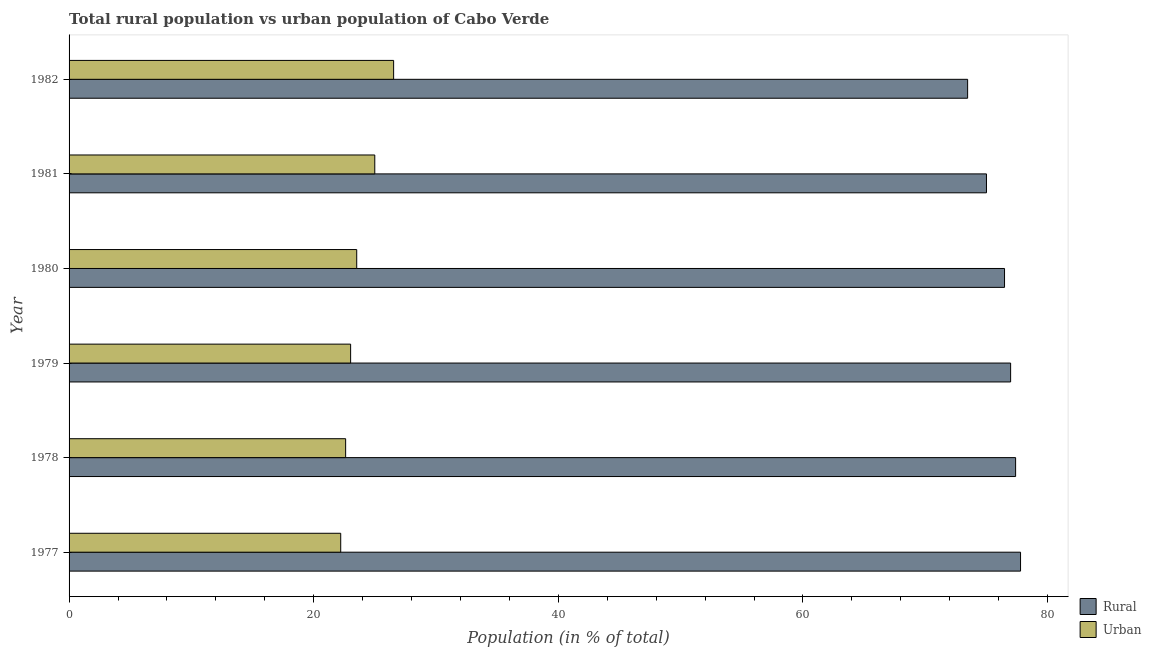How many groups of bars are there?
Your answer should be very brief. 6. Are the number of bars on each tick of the Y-axis equal?
Give a very brief answer. Yes. How many bars are there on the 3rd tick from the top?
Offer a terse response. 2. What is the label of the 5th group of bars from the top?
Your answer should be compact. 1978. In how many cases, is the number of bars for a given year not equal to the number of legend labels?
Your response must be concise. 0. What is the urban population in 1980?
Your answer should be compact. 23.52. Across all years, what is the maximum rural population?
Your answer should be compact. 77.79. Across all years, what is the minimum rural population?
Give a very brief answer. 73.47. In which year was the urban population minimum?
Your response must be concise. 1977. What is the total rural population in the graph?
Ensure brevity in your answer.  457.11. What is the difference between the urban population in 1979 and that in 1982?
Make the answer very short. -3.52. What is the difference between the urban population in 1977 and the rural population in 1978?
Provide a short and direct response. -55.18. What is the average rural population per year?
Your response must be concise. 76.19. In the year 1977, what is the difference between the urban population and rural population?
Keep it short and to the point. -55.58. In how many years, is the urban population greater than 32 %?
Provide a short and direct response. 0. What is the ratio of the rural population in 1980 to that in 1981?
Ensure brevity in your answer.  1.02. What is the difference between the highest and the second highest rural population?
Provide a succinct answer. 0.4. What is the difference between the highest and the lowest urban population?
Ensure brevity in your answer.  4.33. In how many years, is the urban population greater than the average urban population taken over all years?
Offer a very short reply. 2. Is the sum of the rural population in 1979 and 1981 greater than the maximum urban population across all years?
Your answer should be very brief. Yes. What does the 1st bar from the top in 1981 represents?
Make the answer very short. Urban. What does the 2nd bar from the bottom in 1977 represents?
Provide a short and direct response. Urban. How many bars are there?
Offer a very short reply. 12. How many years are there in the graph?
Offer a very short reply. 6. Are the values on the major ticks of X-axis written in scientific E-notation?
Offer a terse response. No. Where does the legend appear in the graph?
Offer a terse response. Bottom right. How many legend labels are there?
Provide a short and direct response. 2. How are the legend labels stacked?
Keep it short and to the point. Vertical. What is the title of the graph?
Provide a succinct answer. Total rural population vs urban population of Cabo Verde. What is the label or title of the X-axis?
Ensure brevity in your answer.  Population (in % of total). What is the Population (in % of total) of Rural in 1977?
Your answer should be very brief. 77.79. What is the Population (in % of total) in Urban in 1977?
Provide a short and direct response. 22.21. What is the Population (in % of total) in Rural in 1978?
Your answer should be very brief. 77.39. What is the Population (in % of total) of Urban in 1978?
Your answer should be compact. 22.61. What is the Population (in % of total) in Rural in 1979?
Ensure brevity in your answer.  76.98. What is the Population (in % of total) of Urban in 1979?
Make the answer very short. 23.02. What is the Population (in % of total) in Rural in 1980?
Provide a short and direct response. 76.48. What is the Population (in % of total) of Urban in 1980?
Offer a very short reply. 23.52. What is the Population (in % of total) of Rural in 1981?
Ensure brevity in your answer.  75. What is the Population (in % of total) in Urban in 1981?
Your answer should be very brief. 25. What is the Population (in % of total) of Rural in 1982?
Your answer should be compact. 73.47. What is the Population (in % of total) of Urban in 1982?
Offer a terse response. 26.54. Across all years, what is the maximum Population (in % of total) of Rural?
Provide a short and direct response. 77.79. Across all years, what is the maximum Population (in % of total) in Urban?
Your answer should be compact. 26.54. Across all years, what is the minimum Population (in % of total) of Rural?
Your answer should be very brief. 73.47. Across all years, what is the minimum Population (in % of total) in Urban?
Your response must be concise. 22.21. What is the total Population (in % of total) in Rural in the graph?
Your answer should be compact. 457.11. What is the total Population (in % of total) in Urban in the graph?
Provide a succinct answer. 142.89. What is the difference between the Population (in % of total) of Rural in 1977 and that in 1978?
Make the answer very short. 0.4. What is the difference between the Population (in % of total) of Urban in 1977 and that in 1978?
Your answer should be compact. -0.4. What is the difference between the Population (in % of total) in Rural in 1977 and that in 1979?
Your answer should be compact. 0.81. What is the difference between the Population (in % of total) in Urban in 1977 and that in 1979?
Your answer should be very brief. -0.81. What is the difference between the Population (in % of total) in Rural in 1977 and that in 1980?
Keep it short and to the point. 1.31. What is the difference between the Population (in % of total) of Urban in 1977 and that in 1980?
Your answer should be very brief. -1.31. What is the difference between the Population (in % of total) of Rural in 1977 and that in 1981?
Your answer should be very brief. 2.79. What is the difference between the Population (in % of total) in Urban in 1977 and that in 1981?
Provide a succinct answer. -2.79. What is the difference between the Population (in % of total) in Rural in 1977 and that in 1982?
Ensure brevity in your answer.  4.33. What is the difference between the Population (in % of total) of Urban in 1977 and that in 1982?
Ensure brevity in your answer.  -4.33. What is the difference between the Population (in % of total) in Rural in 1978 and that in 1979?
Your answer should be very brief. 0.41. What is the difference between the Population (in % of total) in Urban in 1978 and that in 1979?
Offer a terse response. -0.41. What is the difference between the Population (in % of total) in Rural in 1978 and that in 1980?
Your response must be concise. 0.91. What is the difference between the Population (in % of total) of Urban in 1978 and that in 1980?
Your answer should be very brief. -0.91. What is the difference between the Population (in % of total) in Rural in 1978 and that in 1981?
Make the answer very short. 2.38. What is the difference between the Population (in % of total) of Urban in 1978 and that in 1981?
Your response must be concise. -2.38. What is the difference between the Population (in % of total) of Rural in 1978 and that in 1982?
Provide a short and direct response. 3.92. What is the difference between the Population (in % of total) in Urban in 1978 and that in 1982?
Ensure brevity in your answer.  -3.92. What is the difference between the Population (in % of total) in Rural in 1979 and that in 1980?
Your answer should be compact. 0.5. What is the difference between the Population (in % of total) of Urban in 1979 and that in 1980?
Provide a succinct answer. -0.5. What is the difference between the Population (in % of total) of Rural in 1979 and that in 1981?
Ensure brevity in your answer.  1.98. What is the difference between the Population (in % of total) in Urban in 1979 and that in 1981?
Provide a short and direct response. -1.98. What is the difference between the Population (in % of total) of Rural in 1979 and that in 1982?
Your answer should be compact. 3.52. What is the difference between the Population (in % of total) in Urban in 1979 and that in 1982?
Your answer should be compact. -3.52. What is the difference between the Population (in % of total) in Rural in 1980 and that in 1981?
Provide a short and direct response. 1.48. What is the difference between the Population (in % of total) in Urban in 1980 and that in 1981?
Make the answer very short. -1.48. What is the difference between the Population (in % of total) of Rural in 1980 and that in 1982?
Offer a very short reply. 3.02. What is the difference between the Population (in % of total) in Urban in 1980 and that in 1982?
Offer a terse response. -3.02. What is the difference between the Population (in % of total) in Rural in 1981 and that in 1982?
Keep it short and to the point. 1.54. What is the difference between the Population (in % of total) in Urban in 1981 and that in 1982?
Your response must be concise. -1.54. What is the difference between the Population (in % of total) of Rural in 1977 and the Population (in % of total) of Urban in 1978?
Your answer should be very brief. 55.18. What is the difference between the Population (in % of total) of Rural in 1977 and the Population (in % of total) of Urban in 1979?
Provide a succinct answer. 54.77. What is the difference between the Population (in % of total) in Rural in 1977 and the Population (in % of total) in Urban in 1980?
Your answer should be compact. 54.27. What is the difference between the Population (in % of total) of Rural in 1977 and the Population (in % of total) of Urban in 1981?
Offer a very short reply. 52.8. What is the difference between the Population (in % of total) in Rural in 1977 and the Population (in % of total) in Urban in 1982?
Offer a very short reply. 51.26. What is the difference between the Population (in % of total) of Rural in 1978 and the Population (in % of total) of Urban in 1979?
Provide a short and direct response. 54.37. What is the difference between the Population (in % of total) in Rural in 1978 and the Population (in % of total) in Urban in 1980?
Your response must be concise. 53.87. What is the difference between the Population (in % of total) in Rural in 1978 and the Population (in % of total) in Urban in 1981?
Your answer should be very brief. 52.39. What is the difference between the Population (in % of total) of Rural in 1978 and the Population (in % of total) of Urban in 1982?
Offer a very short reply. 50.85. What is the difference between the Population (in % of total) of Rural in 1979 and the Population (in % of total) of Urban in 1980?
Keep it short and to the point. 53.46. What is the difference between the Population (in % of total) of Rural in 1979 and the Population (in % of total) of Urban in 1981?
Ensure brevity in your answer.  51.98. What is the difference between the Population (in % of total) of Rural in 1979 and the Population (in % of total) of Urban in 1982?
Ensure brevity in your answer.  50.45. What is the difference between the Population (in % of total) in Rural in 1980 and the Population (in % of total) in Urban in 1981?
Provide a succinct answer. 51.49. What is the difference between the Population (in % of total) of Rural in 1980 and the Population (in % of total) of Urban in 1982?
Your answer should be compact. 49.95. What is the difference between the Population (in % of total) in Rural in 1981 and the Population (in % of total) in Urban in 1982?
Your answer should be compact. 48.47. What is the average Population (in % of total) of Rural per year?
Your response must be concise. 76.19. What is the average Population (in % of total) in Urban per year?
Your answer should be compact. 23.81. In the year 1977, what is the difference between the Population (in % of total) of Rural and Population (in % of total) of Urban?
Keep it short and to the point. 55.58. In the year 1978, what is the difference between the Population (in % of total) of Rural and Population (in % of total) of Urban?
Ensure brevity in your answer.  54.78. In the year 1979, what is the difference between the Population (in % of total) of Rural and Population (in % of total) of Urban?
Give a very brief answer. 53.96. In the year 1980, what is the difference between the Population (in % of total) of Rural and Population (in % of total) of Urban?
Offer a terse response. 52.96. In the year 1981, what is the difference between the Population (in % of total) of Rural and Population (in % of total) of Urban?
Provide a short and direct response. 50.01. In the year 1982, what is the difference between the Population (in % of total) of Rural and Population (in % of total) of Urban?
Provide a short and direct response. 46.93. What is the ratio of the Population (in % of total) in Urban in 1977 to that in 1978?
Give a very brief answer. 0.98. What is the ratio of the Population (in % of total) of Rural in 1977 to that in 1979?
Offer a very short reply. 1.01. What is the ratio of the Population (in % of total) of Urban in 1977 to that in 1979?
Provide a succinct answer. 0.96. What is the ratio of the Population (in % of total) in Rural in 1977 to that in 1980?
Keep it short and to the point. 1.02. What is the ratio of the Population (in % of total) of Urban in 1977 to that in 1980?
Give a very brief answer. 0.94. What is the ratio of the Population (in % of total) in Rural in 1977 to that in 1981?
Make the answer very short. 1.04. What is the ratio of the Population (in % of total) in Urban in 1977 to that in 1981?
Provide a succinct answer. 0.89. What is the ratio of the Population (in % of total) of Rural in 1977 to that in 1982?
Your response must be concise. 1.06. What is the ratio of the Population (in % of total) of Urban in 1977 to that in 1982?
Ensure brevity in your answer.  0.84. What is the ratio of the Population (in % of total) in Rural in 1978 to that in 1979?
Your answer should be very brief. 1.01. What is the ratio of the Population (in % of total) in Urban in 1978 to that in 1979?
Your answer should be compact. 0.98. What is the ratio of the Population (in % of total) in Rural in 1978 to that in 1980?
Ensure brevity in your answer.  1.01. What is the ratio of the Population (in % of total) in Urban in 1978 to that in 1980?
Your response must be concise. 0.96. What is the ratio of the Population (in % of total) of Rural in 1978 to that in 1981?
Provide a short and direct response. 1.03. What is the ratio of the Population (in % of total) in Urban in 1978 to that in 1981?
Your response must be concise. 0.9. What is the ratio of the Population (in % of total) of Rural in 1978 to that in 1982?
Offer a terse response. 1.05. What is the ratio of the Population (in % of total) in Urban in 1978 to that in 1982?
Provide a succinct answer. 0.85. What is the ratio of the Population (in % of total) of Urban in 1979 to that in 1980?
Provide a short and direct response. 0.98. What is the ratio of the Population (in % of total) in Rural in 1979 to that in 1981?
Your answer should be very brief. 1.03. What is the ratio of the Population (in % of total) of Urban in 1979 to that in 1981?
Ensure brevity in your answer.  0.92. What is the ratio of the Population (in % of total) in Rural in 1979 to that in 1982?
Ensure brevity in your answer.  1.05. What is the ratio of the Population (in % of total) of Urban in 1979 to that in 1982?
Make the answer very short. 0.87. What is the ratio of the Population (in % of total) in Rural in 1980 to that in 1981?
Your answer should be compact. 1.02. What is the ratio of the Population (in % of total) in Urban in 1980 to that in 1981?
Your response must be concise. 0.94. What is the ratio of the Population (in % of total) in Rural in 1980 to that in 1982?
Ensure brevity in your answer.  1.04. What is the ratio of the Population (in % of total) in Urban in 1980 to that in 1982?
Give a very brief answer. 0.89. What is the ratio of the Population (in % of total) in Urban in 1981 to that in 1982?
Your answer should be compact. 0.94. What is the difference between the highest and the second highest Population (in % of total) of Rural?
Your response must be concise. 0.4. What is the difference between the highest and the second highest Population (in % of total) of Urban?
Your response must be concise. 1.54. What is the difference between the highest and the lowest Population (in % of total) of Rural?
Provide a succinct answer. 4.33. What is the difference between the highest and the lowest Population (in % of total) in Urban?
Offer a very short reply. 4.33. 